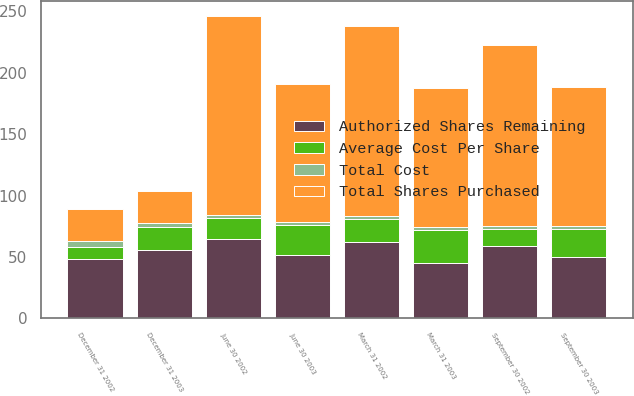Convert chart. <chart><loc_0><loc_0><loc_500><loc_500><stacked_bar_chart><ecel><fcel>March 31 2002<fcel>June 30 2002<fcel>September 30 2002<fcel>December 31 2002<fcel>March 31 2003<fcel>June 30 2003<fcel>September 30 2003<fcel>December 31 2003<nl><fcel>Total Cost<fcel>2.5<fcel>2.5<fcel>2.5<fcel>4.35<fcel>2.5<fcel>2.2<fcel>2.26<fcel>3.44<nl><fcel>Authorized Shares Remaining<fcel>61.92<fcel>64.83<fcel>58.87<fcel>48.61<fcel>45.11<fcel>51.22<fcel>50.05<fcel>55.27<nl><fcel>Total Shares Purchased<fcel>154.8<fcel>162.1<fcel>147.2<fcel>26.05<fcel>112.8<fcel>112.7<fcel>113.1<fcel>26.05<nl><fcel>Average Cost Per Share<fcel>19<fcel>16.5<fcel>14<fcel>9.65<fcel>27.15<fcel>24.95<fcel>22.69<fcel>19.25<nl></chart> 